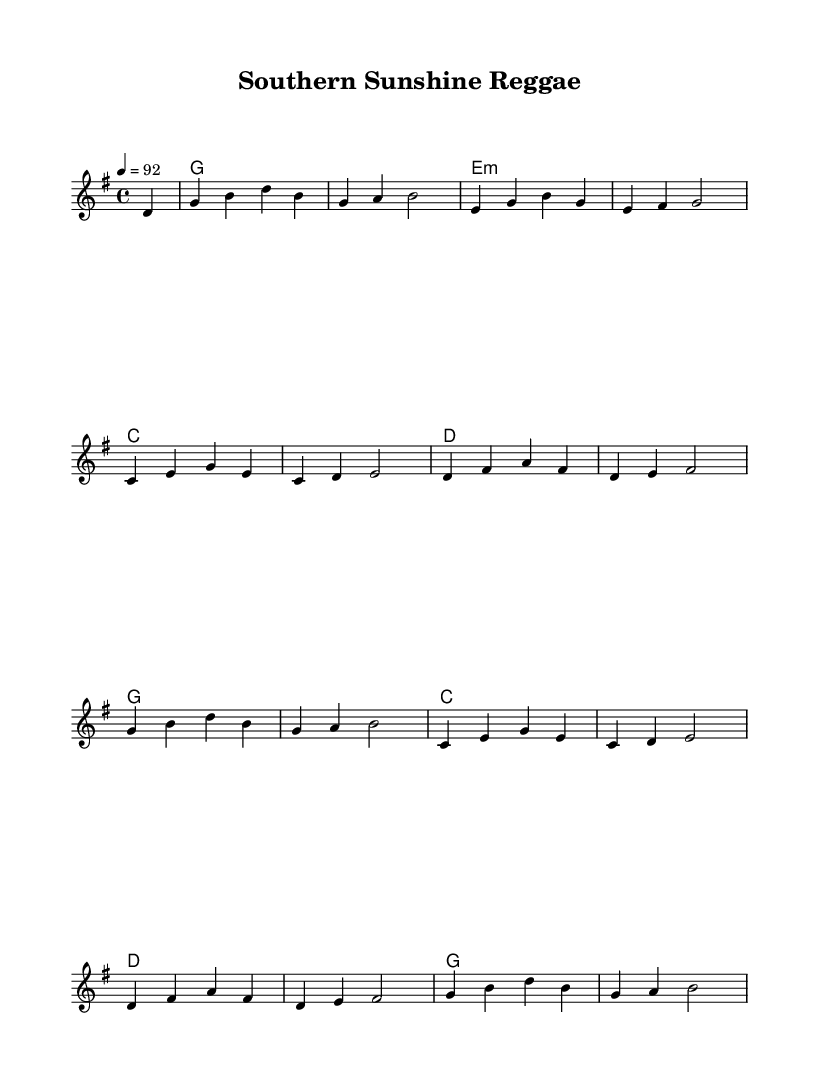What is the key signature of this music? The key signature is G major, which has one sharp (F#). This can be identified by inspecting the sign at the beginning of the staff.
Answer: G major What is the time signature of this music? The time signature is 4/4, which means there are four beats per measure and the quarter note receives one beat. This is indicated at the beginning of the staff.
Answer: 4/4 What is the tempo marking for this piece? The tempo marking indicates a speed of 92 beats per minute, which is noted above the staff in the tempo text. This specifies how quickly the piece should be played.
Answer: 92 Which chords are used in the first section of the score? The first section features the chords G, E minor, and C. To determine this, one should examine the chord symbols written above the melody in the chord names section.
Answer: G, E minor, C What distinguishes this piece as a reggae fusion? This piece exhibits syncopated rhythms typical of reggae along with melodic structures borrowed from country and pop, blending elements from these genres. You can observe the rhythmic patterns and harmony choices that reflect this fusion.
Answer: Syncopated rhythms How many measures are there in the melody? The melody consists of 16 measures. One can count the vertical lines separating the measures in the score to determine the total.
Answer: 16 Which instrument is likely to play the melody in this score? The lead voice is typically performed by a melodic instrument or vocalist. The score indicates a voice part labeled as "lead," suggesting it would feature the main melody.
Answer: Lead voice 